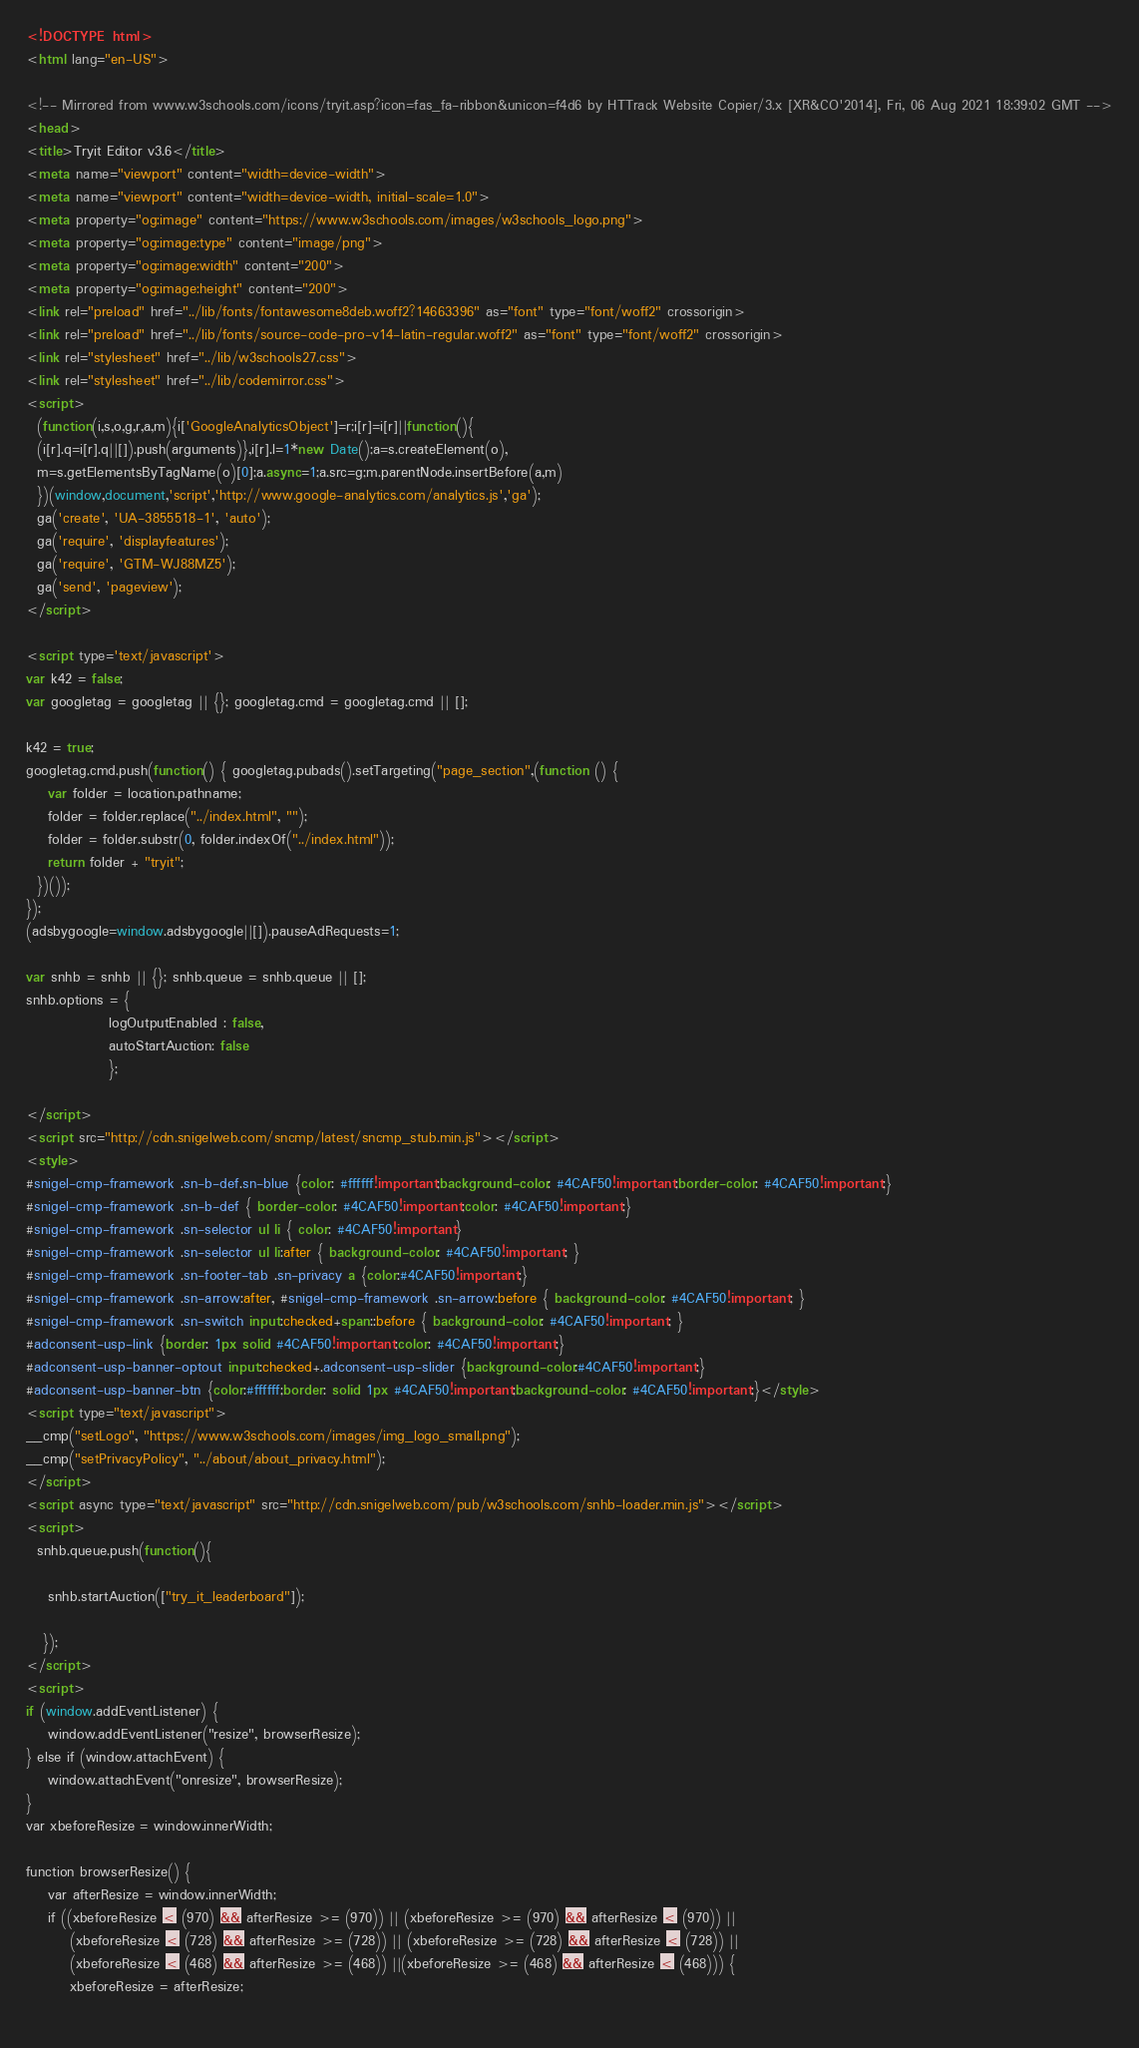<code> <loc_0><loc_0><loc_500><loc_500><_HTML_>
<!DOCTYPE html>
<html lang="en-US">

<!-- Mirrored from www.w3schools.com/icons/tryit.asp?icon=fas_fa-ribbon&unicon=f4d6 by HTTrack Website Copier/3.x [XR&CO'2014], Fri, 06 Aug 2021 18:39:02 GMT -->
<head>
<title>Tryit Editor v3.6</title>
<meta name="viewport" content="width=device-width">
<meta name="viewport" content="width=device-width, initial-scale=1.0">
<meta property="og:image" content="https://www.w3schools.com/images/w3schools_logo.png">
<meta property="og:image:type" content="image/png">
<meta property="og:image:width" content="200">
<meta property="og:image:height" content="200">
<link rel="preload" href="../lib/fonts/fontawesome8deb.woff2?14663396" as="font" type="font/woff2" crossorigin> 
<link rel="preload" href="../lib/fonts/source-code-pro-v14-latin-regular.woff2" as="font" type="font/woff2" crossorigin> 
<link rel="stylesheet" href="../lib/w3schools27.css">
<link rel="stylesheet" href="../lib/codemirror.css">
<script>
  (function(i,s,o,g,r,a,m){i['GoogleAnalyticsObject']=r;i[r]=i[r]||function(){
  (i[r].q=i[r].q||[]).push(arguments)},i[r].l=1*new Date();a=s.createElement(o),
  m=s.getElementsByTagName(o)[0];a.async=1;a.src=g;m.parentNode.insertBefore(a,m)
  })(window,document,'script','http://www.google-analytics.com/analytics.js','ga');
  ga('create', 'UA-3855518-1', 'auto');
  ga('require', 'displayfeatures');
  ga('require', 'GTM-WJ88MZ5');
  ga('send', 'pageview');
</script>

<script type='text/javascript'>
var k42 = false;
var googletag = googletag || {}; googletag.cmd = googletag.cmd || [];

k42 = true;
googletag.cmd.push(function() { googletag.pubads().setTargeting("page_section",(function () {
    var folder = location.pathname;
    folder = folder.replace("../index.html", "");
    folder = folder.substr(0, folder.indexOf("../index.html"));
    return folder + "tryit";
  })());
});  
(adsbygoogle=window.adsbygoogle||[]).pauseAdRequests=1;

var snhb = snhb || {}; snhb.queue = snhb.queue || [];
snhb.options = {
               logOutputEnabled : false,
               autoStartAuction: false
               };

</script>
<script src="http://cdn.snigelweb.com/sncmp/latest/sncmp_stub.min.js"></script>
<style>
#snigel-cmp-framework .sn-b-def.sn-blue {color: #ffffff!important;background-color: #4CAF50!important;border-color: #4CAF50!important;}
#snigel-cmp-framework .sn-b-def { border-color: #4CAF50!important;color: #4CAF50!important;}
#snigel-cmp-framework .sn-selector ul li { color: #4CAF50!important}
#snigel-cmp-framework .sn-selector ul li:after { background-color: #4CAF50!important; }
#snigel-cmp-framework .sn-footer-tab .sn-privacy a {color:#4CAF50!important;}
#snigel-cmp-framework .sn-arrow:after, #snigel-cmp-framework .sn-arrow:before { background-color: #4CAF50!important; }
#snigel-cmp-framework .sn-switch input:checked+span::before { background-color: #4CAF50!important; }
#adconsent-usp-link {border: 1px solid #4CAF50!important;color: #4CAF50!important;}
#adconsent-usp-banner-optout input:checked+.adconsent-usp-slider {background-color:#4CAF50!important;}
#adconsent-usp-banner-btn {color:#ffffff;border: solid 1px #4CAF50!important;background-color: #4CAF50!important;}</style>
<script type="text/javascript">
__cmp("setLogo", "https://www.w3schools.com/images/img_logo_small.png");
__cmp("setPrivacyPolicy", "../about/about_privacy.html");
</script>
<script async type="text/javascript" src="http://cdn.snigelweb.com/pub/w3schools.com/snhb-loader.min.js"></script>
<script>
  snhb.queue.push(function(){

    snhb.startAuction(["try_it_leaderboard"]);

   });
</script>
<script>
if (window.addEventListener) {              
    window.addEventListener("resize", browserResize);
} else if (window.attachEvent) {                 
    window.attachEvent("onresize", browserResize);
}
var xbeforeResize = window.innerWidth;

function browserResize() {
    var afterResize = window.innerWidth;
    if ((xbeforeResize < (970) && afterResize >= (970)) || (xbeforeResize >= (970) && afterResize < (970)) ||
        (xbeforeResize < (728) && afterResize >= (728)) || (xbeforeResize >= (728) && afterResize < (728)) ||
        (xbeforeResize < (468) && afterResize >= (468)) ||(xbeforeResize >= (468) && afterResize < (468))) {
        xbeforeResize = afterResize;
        </code> 